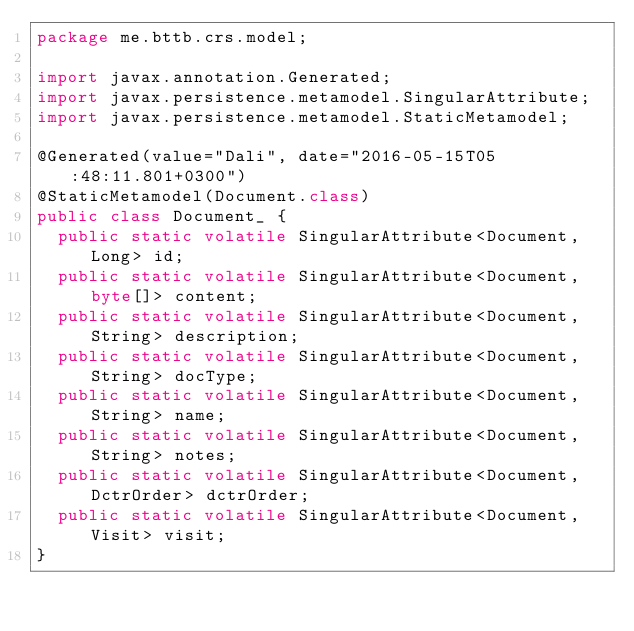Convert code to text. <code><loc_0><loc_0><loc_500><loc_500><_Java_>package me.bttb.crs.model;

import javax.annotation.Generated;
import javax.persistence.metamodel.SingularAttribute;
import javax.persistence.metamodel.StaticMetamodel;

@Generated(value="Dali", date="2016-05-15T05:48:11.801+0300")
@StaticMetamodel(Document.class)
public class Document_ {
	public static volatile SingularAttribute<Document, Long> id;
	public static volatile SingularAttribute<Document, byte[]> content;
	public static volatile SingularAttribute<Document, String> description;
	public static volatile SingularAttribute<Document, String> docType;
	public static volatile SingularAttribute<Document, String> name;
	public static volatile SingularAttribute<Document, String> notes;
	public static volatile SingularAttribute<Document, DctrOrder> dctrOrder;
	public static volatile SingularAttribute<Document, Visit> visit;
}
</code> 